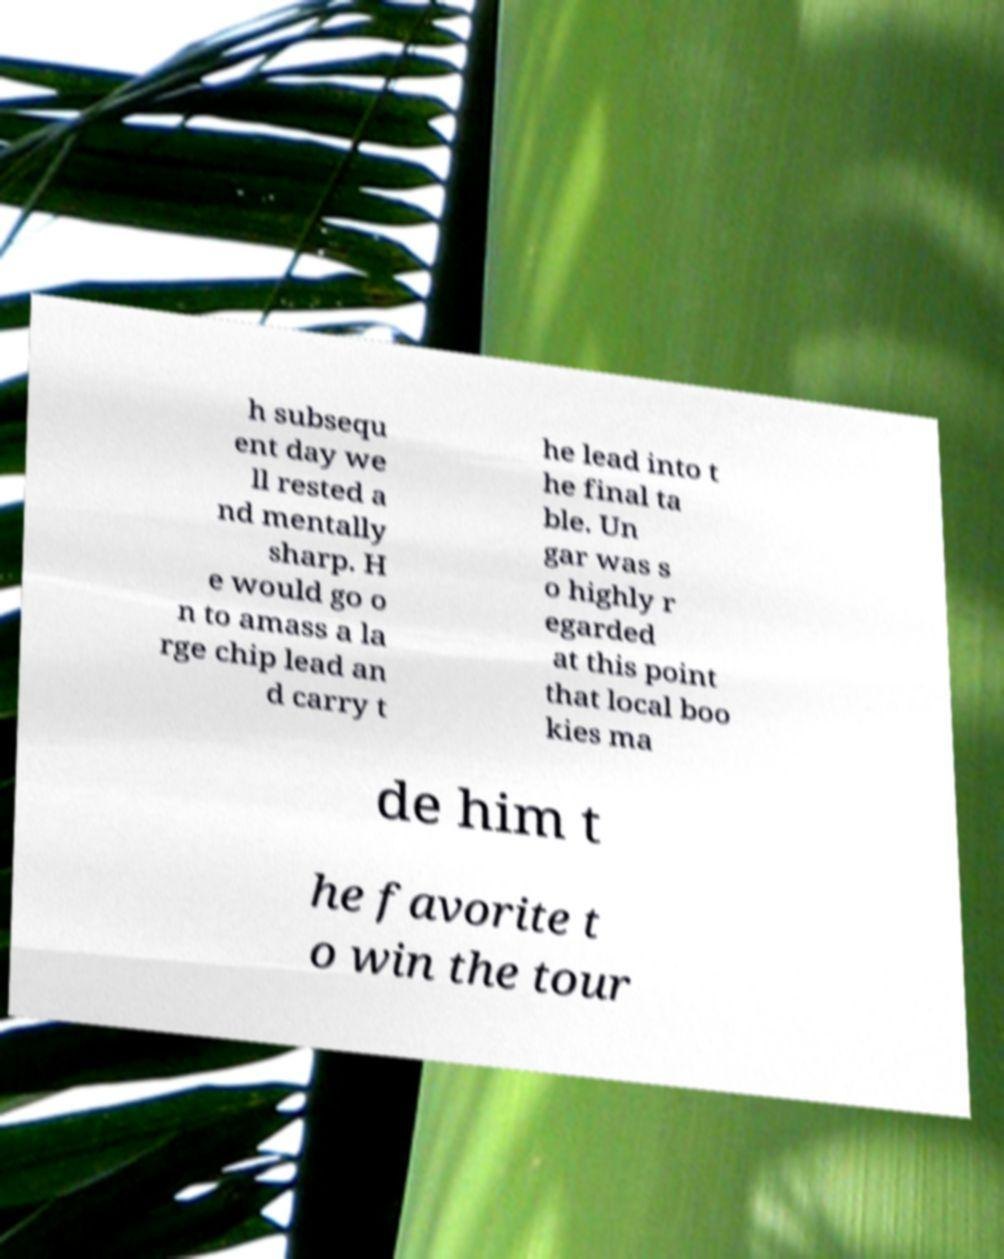Please identify and transcribe the text found in this image. h subsequ ent day we ll rested a nd mentally sharp. H e would go o n to amass a la rge chip lead an d carry t he lead into t he final ta ble. Un gar was s o highly r egarded at this point that local boo kies ma de him t he favorite t o win the tour 